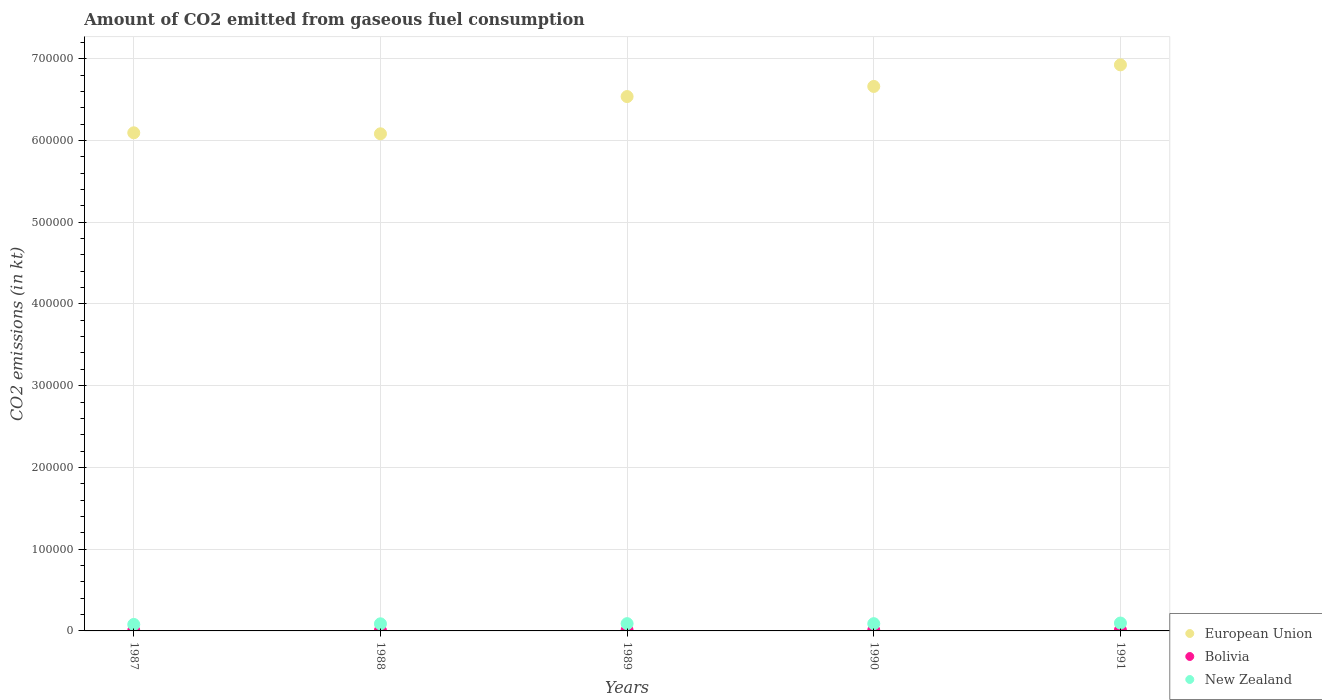What is the amount of CO2 emitted in European Union in 1989?
Provide a succinct answer. 6.54e+05. Across all years, what is the maximum amount of CO2 emitted in Bolivia?
Ensure brevity in your answer.  960.75. Across all years, what is the minimum amount of CO2 emitted in European Union?
Your answer should be compact. 6.08e+05. In which year was the amount of CO2 emitted in New Zealand maximum?
Provide a succinct answer. 1991. What is the total amount of CO2 emitted in New Zealand in the graph?
Keep it short and to the point. 4.40e+04. What is the difference between the amount of CO2 emitted in Bolivia in 1987 and that in 1988?
Your answer should be compact. 11. What is the difference between the amount of CO2 emitted in New Zealand in 1988 and the amount of CO2 emitted in European Union in 1987?
Offer a very short reply. -6.01e+05. What is the average amount of CO2 emitted in New Zealand per year?
Provide a short and direct response. 8804.47. In the year 1990, what is the difference between the amount of CO2 emitted in Bolivia and amount of CO2 emitted in European Union?
Give a very brief answer. -6.65e+05. In how many years, is the amount of CO2 emitted in New Zealand greater than 500000 kt?
Offer a terse response. 0. What is the ratio of the amount of CO2 emitted in European Union in 1988 to that in 1989?
Your answer should be very brief. 0.93. Is the difference between the amount of CO2 emitted in Bolivia in 1987 and 1991 greater than the difference between the amount of CO2 emitted in European Union in 1987 and 1991?
Provide a succinct answer. Yes. What is the difference between the highest and the second highest amount of CO2 emitted in Bolivia?
Ensure brevity in your answer.  33. What is the difference between the highest and the lowest amount of CO2 emitted in Bolivia?
Keep it short and to the point. 366.7. In how many years, is the amount of CO2 emitted in European Union greater than the average amount of CO2 emitted in European Union taken over all years?
Your response must be concise. 3. How many dotlines are there?
Offer a very short reply. 3. Are the values on the major ticks of Y-axis written in scientific E-notation?
Ensure brevity in your answer.  No. Does the graph contain any zero values?
Provide a short and direct response. No. Does the graph contain grids?
Your answer should be very brief. Yes. How many legend labels are there?
Offer a very short reply. 3. What is the title of the graph?
Your response must be concise. Amount of CO2 emitted from gaseous fuel consumption. Does "Peru" appear as one of the legend labels in the graph?
Your response must be concise. No. What is the label or title of the X-axis?
Your answer should be very brief. Years. What is the label or title of the Y-axis?
Offer a very short reply. CO2 emissions (in kt). What is the CO2 emissions (in kt) in European Union in 1987?
Offer a terse response. 6.09e+05. What is the CO2 emissions (in kt) of Bolivia in 1987?
Offer a very short reply. 605.05. What is the CO2 emissions (in kt) in New Zealand in 1987?
Offer a terse response. 7920.72. What is the CO2 emissions (in kt) of European Union in 1988?
Give a very brief answer. 6.08e+05. What is the CO2 emissions (in kt) of Bolivia in 1988?
Your answer should be very brief. 594.05. What is the CO2 emissions (in kt) in New Zealand in 1988?
Ensure brevity in your answer.  8687.12. What is the CO2 emissions (in kt) in European Union in 1989?
Provide a succinct answer. 6.54e+05. What is the CO2 emissions (in kt) of Bolivia in 1989?
Give a very brief answer. 865.41. What is the CO2 emissions (in kt) of New Zealand in 1989?
Make the answer very short. 8903.48. What is the CO2 emissions (in kt) in European Union in 1990?
Offer a terse response. 6.66e+05. What is the CO2 emissions (in kt) in Bolivia in 1990?
Provide a succinct answer. 927.75. What is the CO2 emissions (in kt) of New Zealand in 1990?
Offer a very short reply. 8870.47. What is the CO2 emissions (in kt) of European Union in 1991?
Your response must be concise. 6.92e+05. What is the CO2 emissions (in kt) in Bolivia in 1991?
Offer a terse response. 960.75. What is the CO2 emissions (in kt) of New Zealand in 1991?
Provide a succinct answer. 9640.54. Across all years, what is the maximum CO2 emissions (in kt) of European Union?
Provide a short and direct response. 6.92e+05. Across all years, what is the maximum CO2 emissions (in kt) of Bolivia?
Make the answer very short. 960.75. Across all years, what is the maximum CO2 emissions (in kt) of New Zealand?
Your answer should be very brief. 9640.54. Across all years, what is the minimum CO2 emissions (in kt) in European Union?
Make the answer very short. 6.08e+05. Across all years, what is the minimum CO2 emissions (in kt) of Bolivia?
Keep it short and to the point. 594.05. Across all years, what is the minimum CO2 emissions (in kt) of New Zealand?
Offer a terse response. 7920.72. What is the total CO2 emissions (in kt) of European Union in the graph?
Ensure brevity in your answer.  3.23e+06. What is the total CO2 emissions (in kt) in Bolivia in the graph?
Offer a very short reply. 3953.03. What is the total CO2 emissions (in kt) of New Zealand in the graph?
Ensure brevity in your answer.  4.40e+04. What is the difference between the CO2 emissions (in kt) in European Union in 1987 and that in 1988?
Ensure brevity in your answer.  1218.99. What is the difference between the CO2 emissions (in kt) of Bolivia in 1987 and that in 1988?
Your answer should be compact. 11. What is the difference between the CO2 emissions (in kt) in New Zealand in 1987 and that in 1988?
Your response must be concise. -766.4. What is the difference between the CO2 emissions (in kt) of European Union in 1987 and that in 1989?
Ensure brevity in your answer.  -4.43e+04. What is the difference between the CO2 emissions (in kt) of Bolivia in 1987 and that in 1989?
Keep it short and to the point. -260.36. What is the difference between the CO2 emissions (in kt) in New Zealand in 1987 and that in 1989?
Your response must be concise. -982.76. What is the difference between the CO2 emissions (in kt) in European Union in 1987 and that in 1990?
Offer a very short reply. -5.67e+04. What is the difference between the CO2 emissions (in kt) in Bolivia in 1987 and that in 1990?
Offer a terse response. -322.7. What is the difference between the CO2 emissions (in kt) of New Zealand in 1987 and that in 1990?
Offer a terse response. -949.75. What is the difference between the CO2 emissions (in kt) of European Union in 1987 and that in 1991?
Your answer should be very brief. -8.31e+04. What is the difference between the CO2 emissions (in kt) in Bolivia in 1987 and that in 1991?
Provide a succinct answer. -355.7. What is the difference between the CO2 emissions (in kt) in New Zealand in 1987 and that in 1991?
Your response must be concise. -1719.82. What is the difference between the CO2 emissions (in kt) of European Union in 1988 and that in 1989?
Provide a short and direct response. -4.56e+04. What is the difference between the CO2 emissions (in kt) in Bolivia in 1988 and that in 1989?
Offer a very short reply. -271.36. What is the difference between the CO2 emissions (in kt) of New Zealand in 1988 and that in 1989?
Your response must be concise. -216.35. What is the difference between the CO2 emissions (in kt) in European Union in 1988 and that in 1990?
Provide a succinct answer. -5.79e+04. What is the difference between the CO2 emissions (in kt) of Bolivia in 1988 and that in 1990?
Keep it short and to the point. -333.7. What is the difference between the CO2 emissions (in kt) in New Zealand in 1988 and that in 1990?
Ensure brevity in your answer.  -183.35. What is the difference between the CO2 emissions (in kt) of European Union in 1988 and that in 1991?
Your answer should be compact. -8.43e+04. What is the difference between the CO2 emissions (in kt) of Bolivia in 1988 and that in 1991?
Make the answer very short. -366.7. What is the difference between the CO2 emissions (in kt) of New Zealand in 1988 and that in 1991?
Provide a short and direct response. -953.42. What is the difference between the CO2 emissions (in kt) of European Union in 1989 and that in 1990?
Offer a very short reply. -1.24e+04. What is the difference between the CO2 emissions (in kt) in Bolivia in 1989 and that in 1990?
Make the answer very short. -62.34. What is the difference between the CO2 emissions (in kt) in New Zealand in 1989 and that in 1990?
Keep it short and to the point. 33. What is the difference between the CO2 emissions (in kt) in European Union in 1989 and that in 1991?
Offer a terse response. -3.88e+04. What is the difference between the CO2 emissions (in kt) of Bolivia in 1989 and that in 1991?
Ensure brevity in your answer.  -95.34. What is the difference between the CO2 emissions (in kt) of New Zealand in 1989 and that in 1991?
Provide a succinct answer. -737.07. What is the difference between the CO2 emissions (in kt) in European Union in 1990 and that in 1991?
Your answer should be very brief. -2.64e+04. What is the difference between the CO2 emissions (in kt) of Bolivia in 1990 and that in 1991?
Make the answer very short. -33. What is the difference between the CO2 emissions (in kt) in New Zealand in 1990 and that in 1991?
Offer a very short reply. -770.07. What is the difference between the CO2 emissions (in kt) of European Union in 1987 and the CO2 emissions (in kt) of Bolivia in 1988?
Your answer should be very brief. 6.09e+05. What is the difference between the CO2 emissions (in kt) of European Union in 1987 and the CO2 emissions (in kt) of New Zealand in 1988?
Provide a short and direct response. 6.01e+05. What is the difference between the CO2 emissions (in kt) in Bolivia in 1987 and the CO2 emissions (in kt) in New Zealand in 1988?
Provide a short and direct response. -8082.07. What is the difference between the CO2 emissions (in kt) in European Union in 1987 and the CO2 emissions (in kt) in Bolivia in 1989?
Your answer should be compact. 6.08e+05. What is the difference between the CO2 emissions (in kt) of European Union in 1987 and the CO2 emissions (in kt) of New Zealand in 1989?
Provide a short and direct response. 6.00e+05. What is the difference between the CO2 emissions (in kt) of Bolivia in 1987 and the CO2 emissions (in kt) of New Zealand in 1989?
Your response must be concise. -8298.42. What is the difference between the CO2 emissions (in kt) in European Union in 1987 and the CO2 emissions (in kt) in Bolivia in 1990?
Offer a very short reply. 6.08e+05. What is the difference between the CO2 emissions (in kt) in European Union in 1987 and the CO2 emissions (in kt) in New Zealand in 1990?
Offer a terse response. 6.00e+05. What is the difference between the CO2 emissions (in kt) of Bolivia in 1987 and the CO2 emissions (in kt) of New Zealand in 1990?
Provide a short and direct response. -8265.42. What is the difference between the CO2 emissions (in kt) of European Union in 1987 and the CO2 emissions (in kt) of Bolivia in 1991?
Your answer should be compact. 6.08e+05. What is the difference between the CO2 emissions (in kt) of European Union in 1987 and the CO2 emissions (in kt) of New Zealand in 1991?
Keep it short and to the point. 6.00e+05. What is the difference between the CO2 emissions (in kt) in Bolivia in 1987 and the CO2 emissions (in kt) in New Zealand in 1991?
Offer a very short reply. -9035.49. What is the difference between the CO2 emissions (in kt) of European Union in 1988 and the CO2 emissions (in kt) of Bolivia in 1989?
Give a very brief answer. 6.07e+05. What is the difference between the CO2 emissions (in kt) of European Union in 1988 and the CO2 emissions (in kt) of New Zealand in 1989?
Provide a succinct answer. 5.99e+05. What is the difference between the CO2 emissions (in kt) in Bolivia in 1988 and the CO2 emissions (in kt) in New Zealand in 1989?
Offer a very short reply. -8309.42. What is the difference between the CO2 emissions (in kt) in European Union in 1988 and the CO2 emissions (in kt) in Bolivia in 1990?
Your answer should be compact. 6.07e+05. What is the difference between the CO2 emissions (in kt) of European Union in 1988 and the CO2 emissions (in kt) of New Zealand in 1990?
Your answer should be very brief. 5.99e+05. What is the difference between the CO2 emissions (in kt) of Bolivia in 1988 and the CO2 emissions (in kt) of New Zealand in 1990?
Your answer should be very brief. -8276.42. What is the difference between the CO2 emissions (in kt) in European Union in 1988 and the CO2 emissions (in kt) in Bolivia in 1991?
Keep it short and to the point. 6.07e+05. What is the difference between the CO2 emissions (in kt) in European Union in 1988 and the CO2 emissions (in kt) in New Zealand in 1991?
Your response must be concise. 5.98e+05. What is the difference between the CO2 emissions (in kt) of Bolivia in 1988 and the CO2 emissions (in kt) of New Zealand in 1991?
Ensure brevity in your answer.  -9046.49. What is the difference between the CO2 emissions (in kt) in European Union in 1989 and the CO2 emissions (in kt) in Bolivia in 1990?
Ensure brevity in your answer.  6.53e+05. What is the difference between the CO2 emissions (in kt) of European Union in 1989 and the CO2 emissions (in kt) of New Zealand in 1990?
Offer a very short reply. 6.45e+05. What is the difference between the CO2 emissions (in kt) in Bolivia in 1989 and the CO2 emissions (in kt) in New Zealand in 1990?
Your answer should be very brief. -8005.06. What is the difference between the CO2 emissions (in kt) in European Union in 1989 and the CO2 emissions (in kt) in Bolivia in 1991?
Give a very brief answer. 6.53e+05. What is the difference between the CO2 emissions (in kt) in European Union in 1989 and the CO2 emissions (in kt) in New Zealand in 1991?
Offer a very short reply. 6.44e+05. What is the difference between the CO2 emissions (in kt) in Bolivia in 1989 and the CO2 emissions (in kt) in New Zealand in 1991?
Your response must be concise. -8775.13. What is the difference between the CO2 emissions (in kt) in European Union in 1990 and the CO2 emissions (in kt) in Bolivia in 1991?
Ensure brevity in your answer.  6.65e+05. What is the difference between the CO2 emissions (in kt) in European Union in 1990 and the CO2 emissions (in kt) in New Zealand in 1991?
Provide a succinct answer. 6.56e+05. What is the difference between the CO2 emissions (in kt) of Bolivia in 1990 and the CO2 emissions (in kt) of New Zealand in 1991?
Make the answer very short. -8712.79. What is the average CO2 emissions (in kt) of European Union per year?
Your answer should be very brief. 6.46e+05. What is the average CO2 emissions (in kt) in Bolivia per year?
Make the answer very short. 790.61. What is the average CO2 emissions (in kt) in New Zealand per year?
Give a very brief answer. 8804.47. In the year 1987, what is the difference between the CO2 emissions (in kt) of European Union and CO2 emissions (in kt) of Bolivia?
Offer a terse response. 6.09e+05. In the year 1987, what is the difference between the CO2 emissions (in kt) of European Union and CO2 emissions (in kt) of New Zealand?
Your answer should be compact. 6.01e+05. In the year 1987, what is the difference between the CO2 emissions (in kt) of Bolivia and CO2 emissions (in kt) of New Zealand?
Keep it short and to the point. -7315.66. In the year 1988, what is the difference between the CO2 emissions (in kt) of European Union and CO2 emissions (in kt) of Bolivia?
Your answer should be compact. 6.08e+05. In the year 1988, what is the difference between the CO2 emissions (in kt) in European Union and CO2 emissions (in kt) in New Zealand?
Ensure brevity in your answer.  5.99e+05. In the year 1988, what is the difference between the CO2 emissions (in kt) in Bolivia and CO2 emissions (in kt) in New Zealand?
Your answer should be compact. -8093.07. In the year 1989, what is the difference between the CO2 emissions (in kt) of European Union and CO2 emissions (in kt) of Bolivia?
Provide a succinct answer. 6.53e+05. In the year 1989, what is the difference between the CO2 emissions (in kt) in European Union and CO2 emissions (in kt) in New Zealand?
Ensure brevity in your answer.  6.45e+05. In the year 1989, what is the difference between the CO2 emissions (in kt) of Bolivia and CO2 emissions (in kt) of New Zealand?
Offer a terse response. -8038.06. In the year 1990, what is the difference between the CO2 emissions (in kt) of European Union and CO2 emissions (in kt) of Bolivia?
Offer a terse response. 6.65e+05. In the year 1990, what is the difference between the CO2 emissions (in kt) in European Union and CO2 emissions (in kt) in New Zealand?
Your response must be concise. 6.57e+05. In the year 1990, what is the difference between the CO2 emissions (in kt) of Bolivia and CO2 emissions (in kt) of New Zealand?
Provide a short and direct response. -7942.72. In the year 1991, what is the difference between the CO2 emissions (in kt) in European Union and CO2 emissions (in kt) in Bolivia?
Offer a very short reply. 6.91e+05. In the year 1991, what is the difference between the CO2 emissions (in kt) in European Union and CO2 emissions (in kt) in New Zealand?
Offer a terse response. 6.83e+05. In the year 1991, what is the difference between the CO2 emissions (in kt) in Bolivia and CO2 emissions (in kt) in New Zealand?
Offer a very short reply. -8679.79. What is the ratio of the CO2 emissions (in kt) of Bolivia in 1987 to that in 1988?
Your response must be concise. 1.02. What is the ratio of the CO2 emissions (in kt) of New Zealand in 1987 to that in 1988?
Your answer should be compact. 0.91. What is the ratio of the CO2 emissions (in kt) in European Union in 1987 to that in 1989?
Your response must be concise. 0.93. What is the ratio of the CO2 emissions (in kt) in Bolivia in 1987 to that in 1989?
Ensure brevity in your answer.  0.7. What is the ratio of the CO2 emissions (in kt) of New Zealand in 1987 to that in 1989?
Provide a succinct answer. 0.89. What is the ratio of the CO2 emissions (in kt) in European Union in 1987 to that in 1990?
Provide a succinct answer. 0.91. What is the ratio of the CO2 emissions (in kt) of Bolivia in 1987 to that in 1990?
Keep it short and to the point. 0.65. What is the ratio of the CO2 emissions (in kt) in New Zealand in 1987 to that in 1990?
Offer a very short reply. 0.89. What is the ratio of the CO2 emissions (in kt) in Bolivia in 1987 to that in 1991?
Provide a succinct answer. 0.63. What is the ratio of the CO2 emissions (in kt) in New Zealand in 1987 to that in 1991?
Your response must be concise. 0.82. What is the ratio of the CO2 emissions (in kt) of European Union in 1988 to that in 1989?
Keep it short and to the point. 0.93. What is the ratio of the CO2 emissions (in kt) in Bolivia in 1988 to that in 1989?
Give a very brief answer. 0.69. What is the ratio of the CO2 emissions (in kt) in New Zealand in 1988 to that in 1989?
Make the answer very short. 0.98. What is the ratio of the CO2 emissions (in kt) of European Union in 1988 to that in 1990?
Keep it short and to the point. 0.91. What is the ratio of the CO2 emissions (in kt) of Bolivia in 1988 to that in 1990?
Ensure brevity in your answer.  0.64. What is the ratio of the CO2 emissions (in kt) of New Zealand in 1988 to that in 1990?
Your answer should be very brief. 0.98. What is the ratio of the CO2 emissions (in kt) of European Union in 1988 to that in 1991?
Provide a short and direct response. 0.88. What is the ratio of the CO2 emissions (in kt) of Bolivia in 1988 to that in 1991?
Your response must be concise. 0.62. What is the ratio of the CO2 emissions (in kt) in New Zealand in 1988 to that in 1991?
Provide a short and direct response. 0.9. What is the ratio of the CO2 emissions (in kt) in European Union in 1989 to that in 1990?
Give a very brief answer. 0.98. What is the ratio of the CO2 emissions (in kt) of Bolivia in 1989 to that in 1990?
Your response must be concise. 0.93. What is the ratio of the CO2 emissions (in kt) of New Zealand in 1989 to that in 1990?
Give a very brief answer. 1. What is the ratio of the CO2 emissions (in kt) in European Union in 1989 to that in 1991?
Your answer should be very brief. 0.94. What is the ratio of the CO2 emissions (in kt) in Bolivia in 1989 to that in 1991?
Your response must be concise. 0.9. What is the ratio of the CO2 emissions (in kt) in New Zealand in 1989 to that in 1991?
Your response must be concise. 0.92. What is the ratio of the CO2 emissions (in kt) in European Union in 1990 to that in 1991?
Give a very brief answer. 0.96. What is the ratio of the CO2 emissions (in kt) of Bolivia in 1990 to that in 1991?
Ensure brevity in your answer.  0.97. What is the ratio of the CO2 emissions (in kt) of New Zealand in 1990 to that in 1991?
Your response must be concise. 0.92. What is the difference between the highest and the second highest CO2 emissions (in kt) of European Union?
Your response must be concise. 2.64e+04. What is the difference between the highest and the second highest CO2 emissions (in kt) of Bolivia?
Keep it short and to the point. 33. What is the difference between the highest and the second highest CO2 emissions (in kt) in New Zealand?
Make the answer very short. 737.07. What is the difference between the highest and the lowest CO2 emissions (in kt) of European Union?
Ensure brevity in your answer.  8.43e+04. What is the difference between the highest and the lowest CO2 emissions (in kt) in Bolivia?
Give a very brief answer. 366.7. What is the difference between the highest and the lowest CO2 emissions (in kt) in New Zealand?
Offer a terse response. 1719.82. 